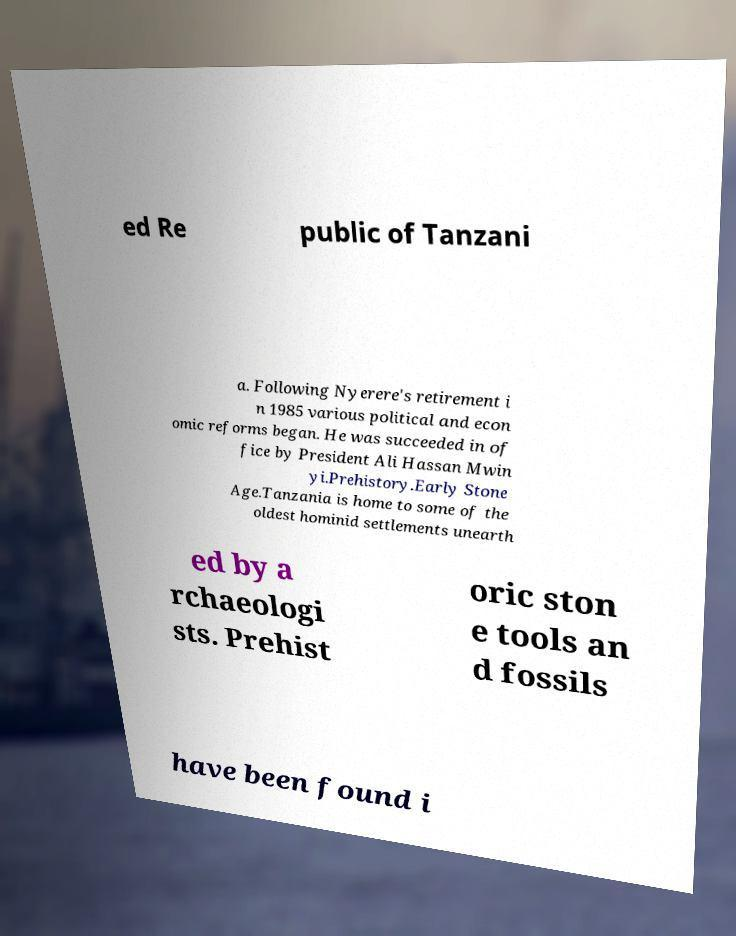For documentation purposes, I need the text within this image transcribed. Could you provide that? ed Re public of Tanzani a. Following Nyerere's retirement i n 1985 various political and econ omic reforms began. He was succeeded in of fice by President Ali Hassan Mwin yi.Prehistory.Early Stone Age.Tanzania is home to some of the oldest hominid settlements unearth ed by a rchaeologi sts. Prehist oric ston e tools an d fossils have been found i 